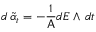<formula> <loc_0><loc_0><loc_500><loc_500>d \, \widetilde { \alpha } _ { t } = - \frac { 1 } { A } d E \wedge \, d t</formula> 